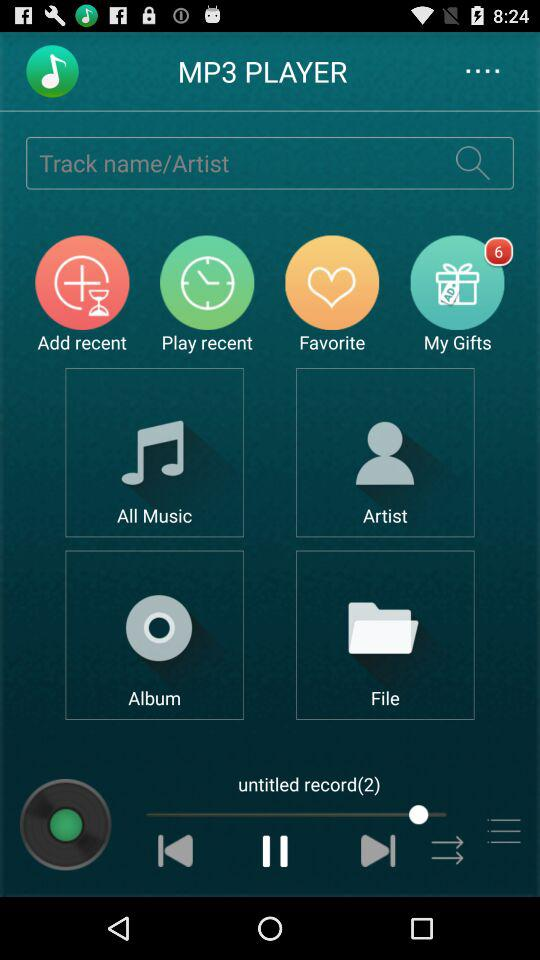How many gifts are in "My Gifts"? There are 6 gifts. 